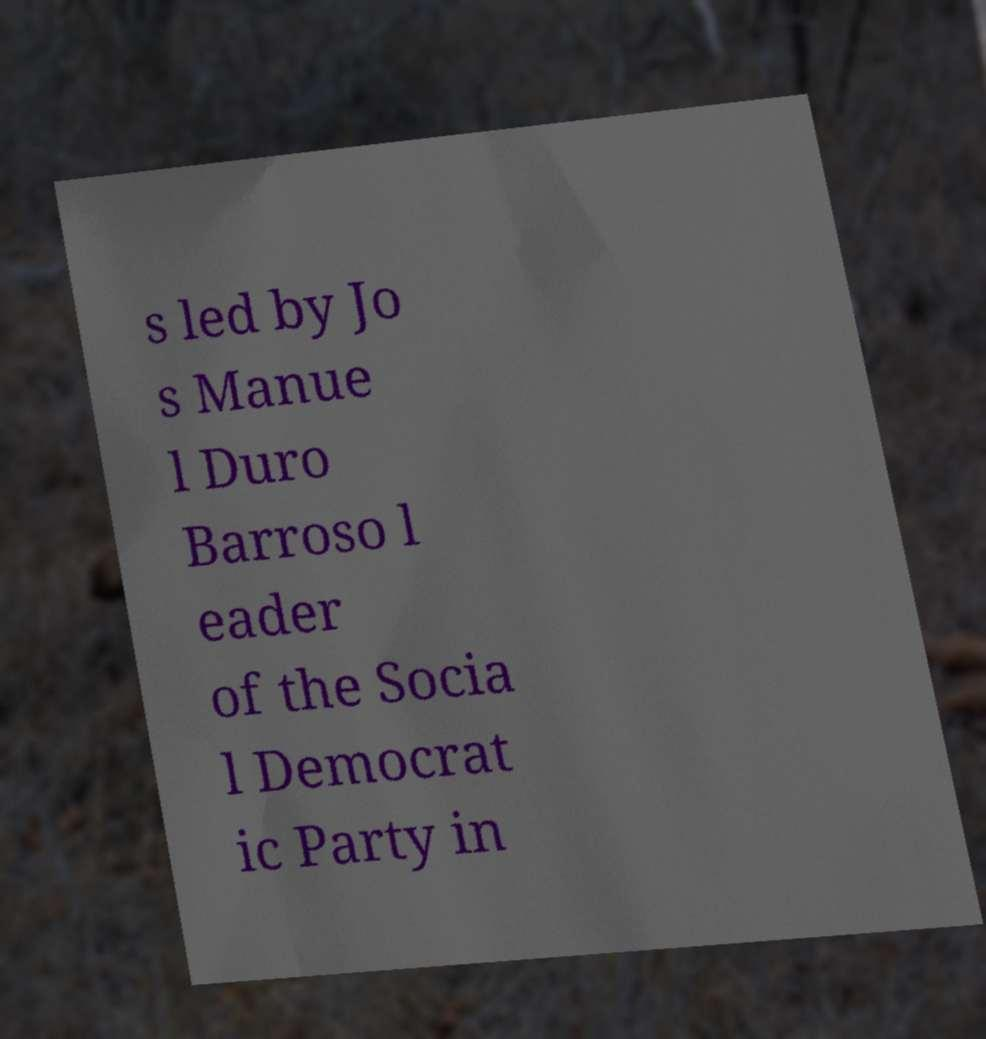For documentation purposes, I need the text within this image transcribed. Could you provide that? s led by Jo s Manue l Duro Barroso l eader of the Socia l Democrat ic Party in 